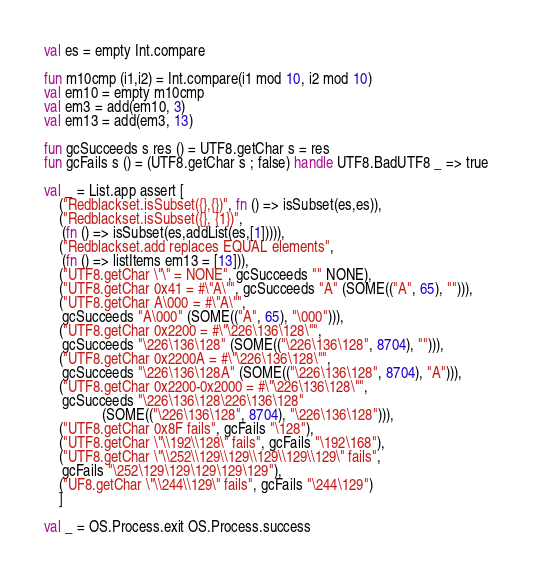<code> <loc_0><loc_0><loc_500><loc_500><_SML_>val es = empty Int.compare

fun m10cmp (i1,i2) = Int.compare(i1 mod 10, i2 mod 10)
val em10 = empty m10cmp
val em3 = add(em10, 3)
val em13 = add(em3, 13)

fun gcSucceeds s res () = UTF8.getChar s = res
fun gcFails s () = (UTF8.getChar s ; false) handle UTF8.BadUTF8 _ => true

val _ = List.app assert [
    ("Redblackset.isSubset({},{})", fn () => isSubset(es,es)),
    ("Redblackset.isSubset({}, {1})",
     (fn () => isSubset(es,addList(es,[1])))),
    ("Redblackset.add replaces EQUAL elements",
     (fn () => listItems em13 = [13])),
    ("UTF8.getChar \"\" = NONE", gcSucceeds "" NONE),
    ("UTF8.getChar 0x41 = #\"A\"", gcSucceeds "A" (SOME(("A", 65), ""))),
    ("UTF8.getChar A\000 = #\"A\"",
     gcSucceeds "A\000" (SOME(("A", 65), "\000"))),
    ("UTF8.getChar 0x2200 = #\"\226\136\128\"",
     gcSucceeds "\226\136\128" (SOME(("\226\136\128", 8704), ""))),
    ("UTF8.getChar 0x2200A = #\"\226\136\128\"",
     gcSucceeds "\226\136\128A" (SOME(("\226\136\128", 8704), "A"))),
    ("UTF8.getChar 0x2200-0x2000 = #\"\226\136\128\"",
     gcSucceeds "\226\136\128\226\136\128"
                (SOME(("\226\136\128", 8704), "\226\136\128"))),
    ("UTF8.getChar 0x8F fails", gcFails "\128"),
    ("UTF8.getChar \"\\192\\128\" fails", gcFails "\192\168"),
    ("UTF8.getChar \"\\252\\129\\129\\129\\129\\129\" fails",
     gcFails "\252\129\129\129\129\129"),
    ("UF8.getChar \"\\244\\129\" fails", gcFails "\244\129")
    ]

val _ = OS.Process.exit OS.Process.success
</code> 